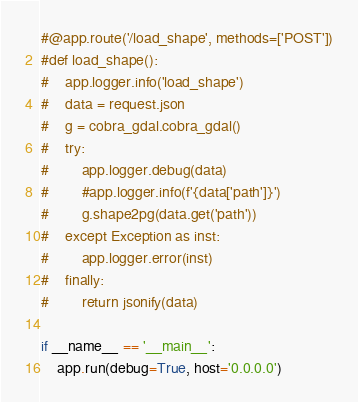<code> <loc_0><loc_0><loc_500><loc_500><_Python_>#@app.route('/load_shape', methods=['POST'])
#def load_shape():
#    app.logger.info('load_shape')
#    data = request.json
#    g = cobra_gdal.cobra_gdal()
#    try:
#        app.logger.debug(data)
#        #app.logger.info(f'{data['path']}')
#        g.shape2pg(data.get('path'))
#    except Exception as inst:
#        app.logger.error(inst)
#    finally:
#        return jsonify(data)

if __name__ == '__main__':
    app.run(debug=True, host='0.0.0.0')</code> 